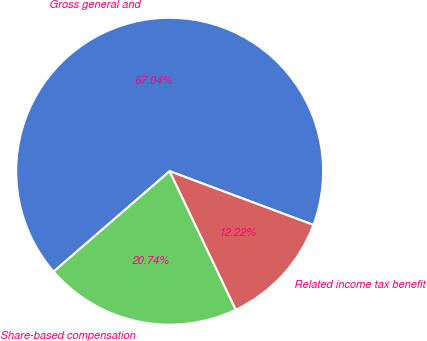<chart> <loc_0><loc_0><loc_500><loc_500><pie_chart><fcel>Gross general and<fcel>Share-based compensation<fcel>Related income tax benefit<nl><fcel>67.04%<fcel>20.74%<fcel>12.22%<nl></chart> 